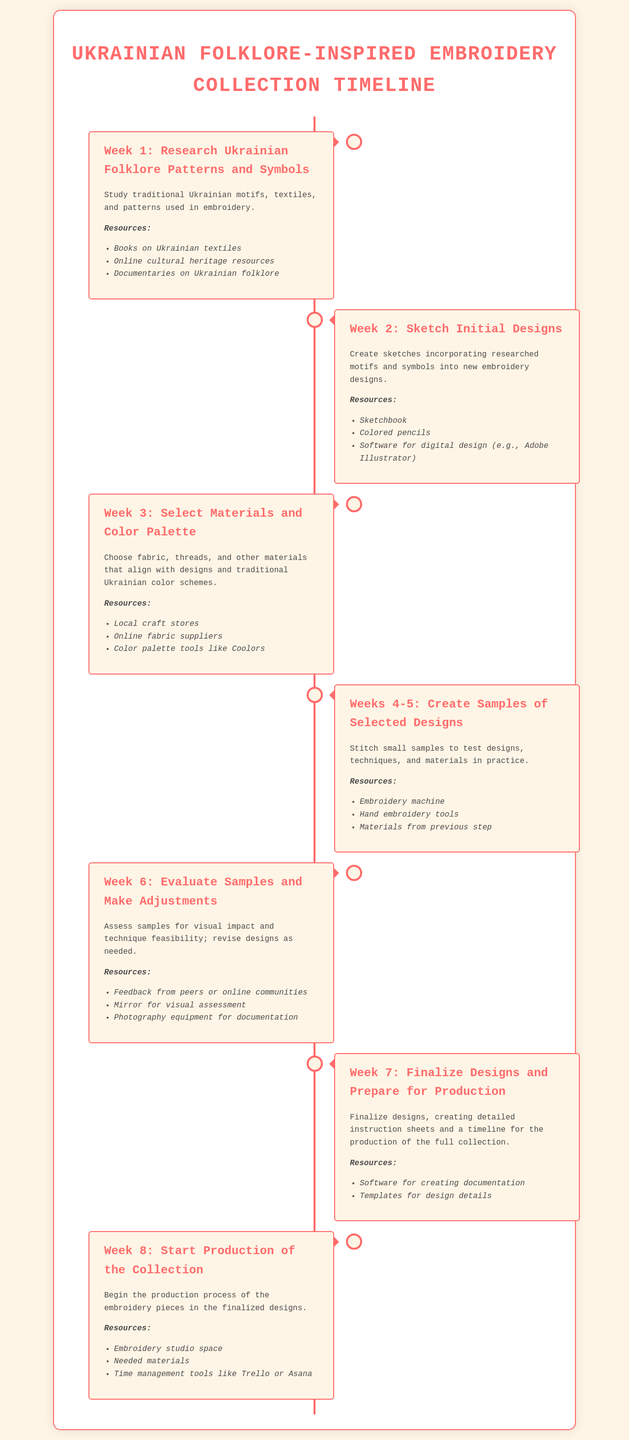What is the title of the document? The title of the document is presented prominently at the top, indicating its purpose and theme.
Answer: Ukrainian Folklore-Inspired Embroidery Collection Timeline How many weeks are included in the project timeline? The document outlines the project across different weeks, which are explicitly mentioned in the timeline items.
Answer: 8 weeks What is the main focus of Week 3? The content for Week 3 clearly specifies the tasks and goals related to material selection and color.
Answer: Select Materials and Color Palette List one resource for Week 1. Each week has a list of resources; one of the resources for Week 1 is specifically listed.
Answer: Books on Ukrainian textiles During which weeks are samples created? The timeline indicates a specific range where sample creation occurs, mentioned explicitly in a timeline item.
Answer: Weeks 4-5 What should be evaluated in Week 6? Week 6 specifies what is to be assessed after the sample creation process.
Answer: Samples What type of tools are suggested for Week 8? The resources for Week 8 mention necessary tools for managing the production process.
Answer: Time management tools like Trello or Asana What activity is performed in Week 2? The main task for Week 2 is clearly stated in the document.
Answer: Sketch Initial Designs 